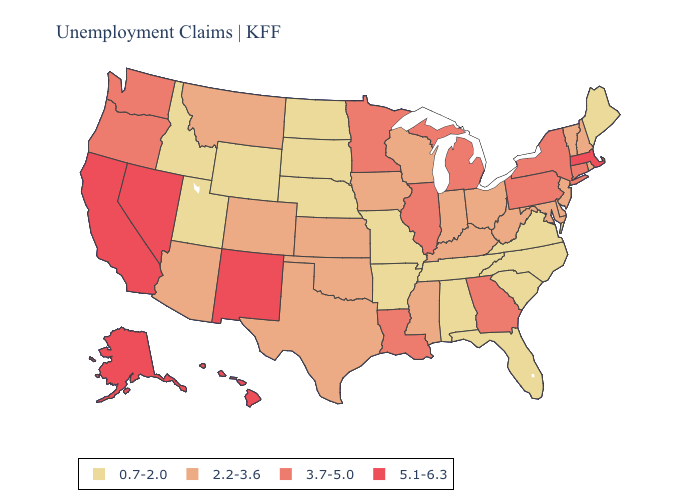Does New York have the highest value in the USA?
Give a very brief answer. No. Name the states that have a value in the range 3.7-5.0?
Short answer required. Connecticut, Georgia, Illinois, Louisiana, Michigan, Minnesota, New York, Oregon, Pennsylvania, Washington. Does North Carolina have the lowest value in the USA?
Concise answer only. Yes. Does Florida have the lowest value in the South?
Concise answer only. Yes. Which states have the lowest value in the West?
Answer briefly. Idaho, Utah, Wyoming. What is the lowest value in the USA?
Quick response, please. 0.7-2.0. Name the states that have a value in the range 5.1-6.3?
Concise answer only. Alaska, California, Hawaii, Massachusetts, Nevada, New Mexico. What is the value of Florida?
Answer briefly. 0.7-2.0. What is the value of North Dakota?
Concise answer only. 0.7-2.0. Among the states that border Pennsylvania , which have the highest value?
Quick response, please. New York. What is the lowest value in states that border Oregon?
Be succinct. 0.7-2.0. Which states have the lowest value in the MidWest?
Be succinct. Missouri, Nebraska, North Dakota, South Dakota. Among the states that border Maine , which have the lowest value?
Be succinct. New Hampshire. Name the states that have a value in the range 5.1-6.3?
Be succinct. Alaska, California, Hawaii, Massachusetts, Nevada, New Mexico. Does Wyoming have the highest value in the West?
Write a very short answer. No. 